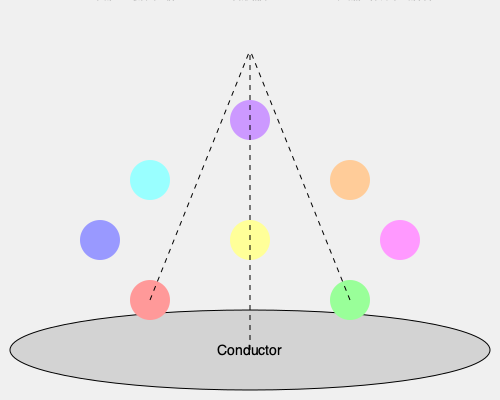In the given orchestral seating arrangement, why are the woodwinds and brass instruments typically placed behind the string section, and how does this affect the overall sound projection and balance of the orchestra? To understand the spatial arrangement of instruments in an orchestra, we need to consider several factors:

1. Sound projection patterns:
   - String instruments (violins, violas, cellos, double basses) have a more directional sound projection, primarily towards the audience.
   - Woodwinds and brass instruments have a more omnidirectional sound projection.

2. Volume and intensity:
   - Brass and woodwind instruments generally produce louder sounds than strings.
   - Placing them behind the strings helps to balance the overall volume.

3. Frequency range:
   - String instruments cover a wide frequency range, from low (double bass) to high (violins).
   - Woodwinds and brass complement this range, filling in the middle and upper frequencies.

4. Acoustic reflection:
   - Sound waves from the brass and woodwinds reflect off the back wall of the concert hall, creating a fuller sound.
   - This reflection helps blend the different instrumental timbres.

5. Visual aesthetics:
   - The arrangement allows the audience to see all instrument groups clearly.
   - It creates a visually pleasing symmetry on stage.

6. Historical precedent:
   - This arrangement has evolved over centuries of orchestral performance practice.

7. Conductor's perspective:
   - The conductor can easily see and communicate with all sections.
   - Brass and woodwinds, being further away, can more easily see the conductor's gestures.

8. Sound mixing:
   - As sound travels from the back of the orchestra to the front, it naturally mixes and blends.
   - This creates a more cohesive orchestral sound before reaching the audience.

9. Dynamic control:
   - Louder instruments (brass, percussion) are further from the audience, allowing for better dynamic control.

The placement of woodwinds and brass behind the strings creates a layered sound projection pattern. The strings provide a foundational layer of sound closest to the audience, while the woodwinds and brass add depth and color from behind. This arrangement allows for optimal blend, balance, and projection of the orchestral sound as a whole.
Answer: Balanced sound projection, optimal blend of timbres, and dynamic control 